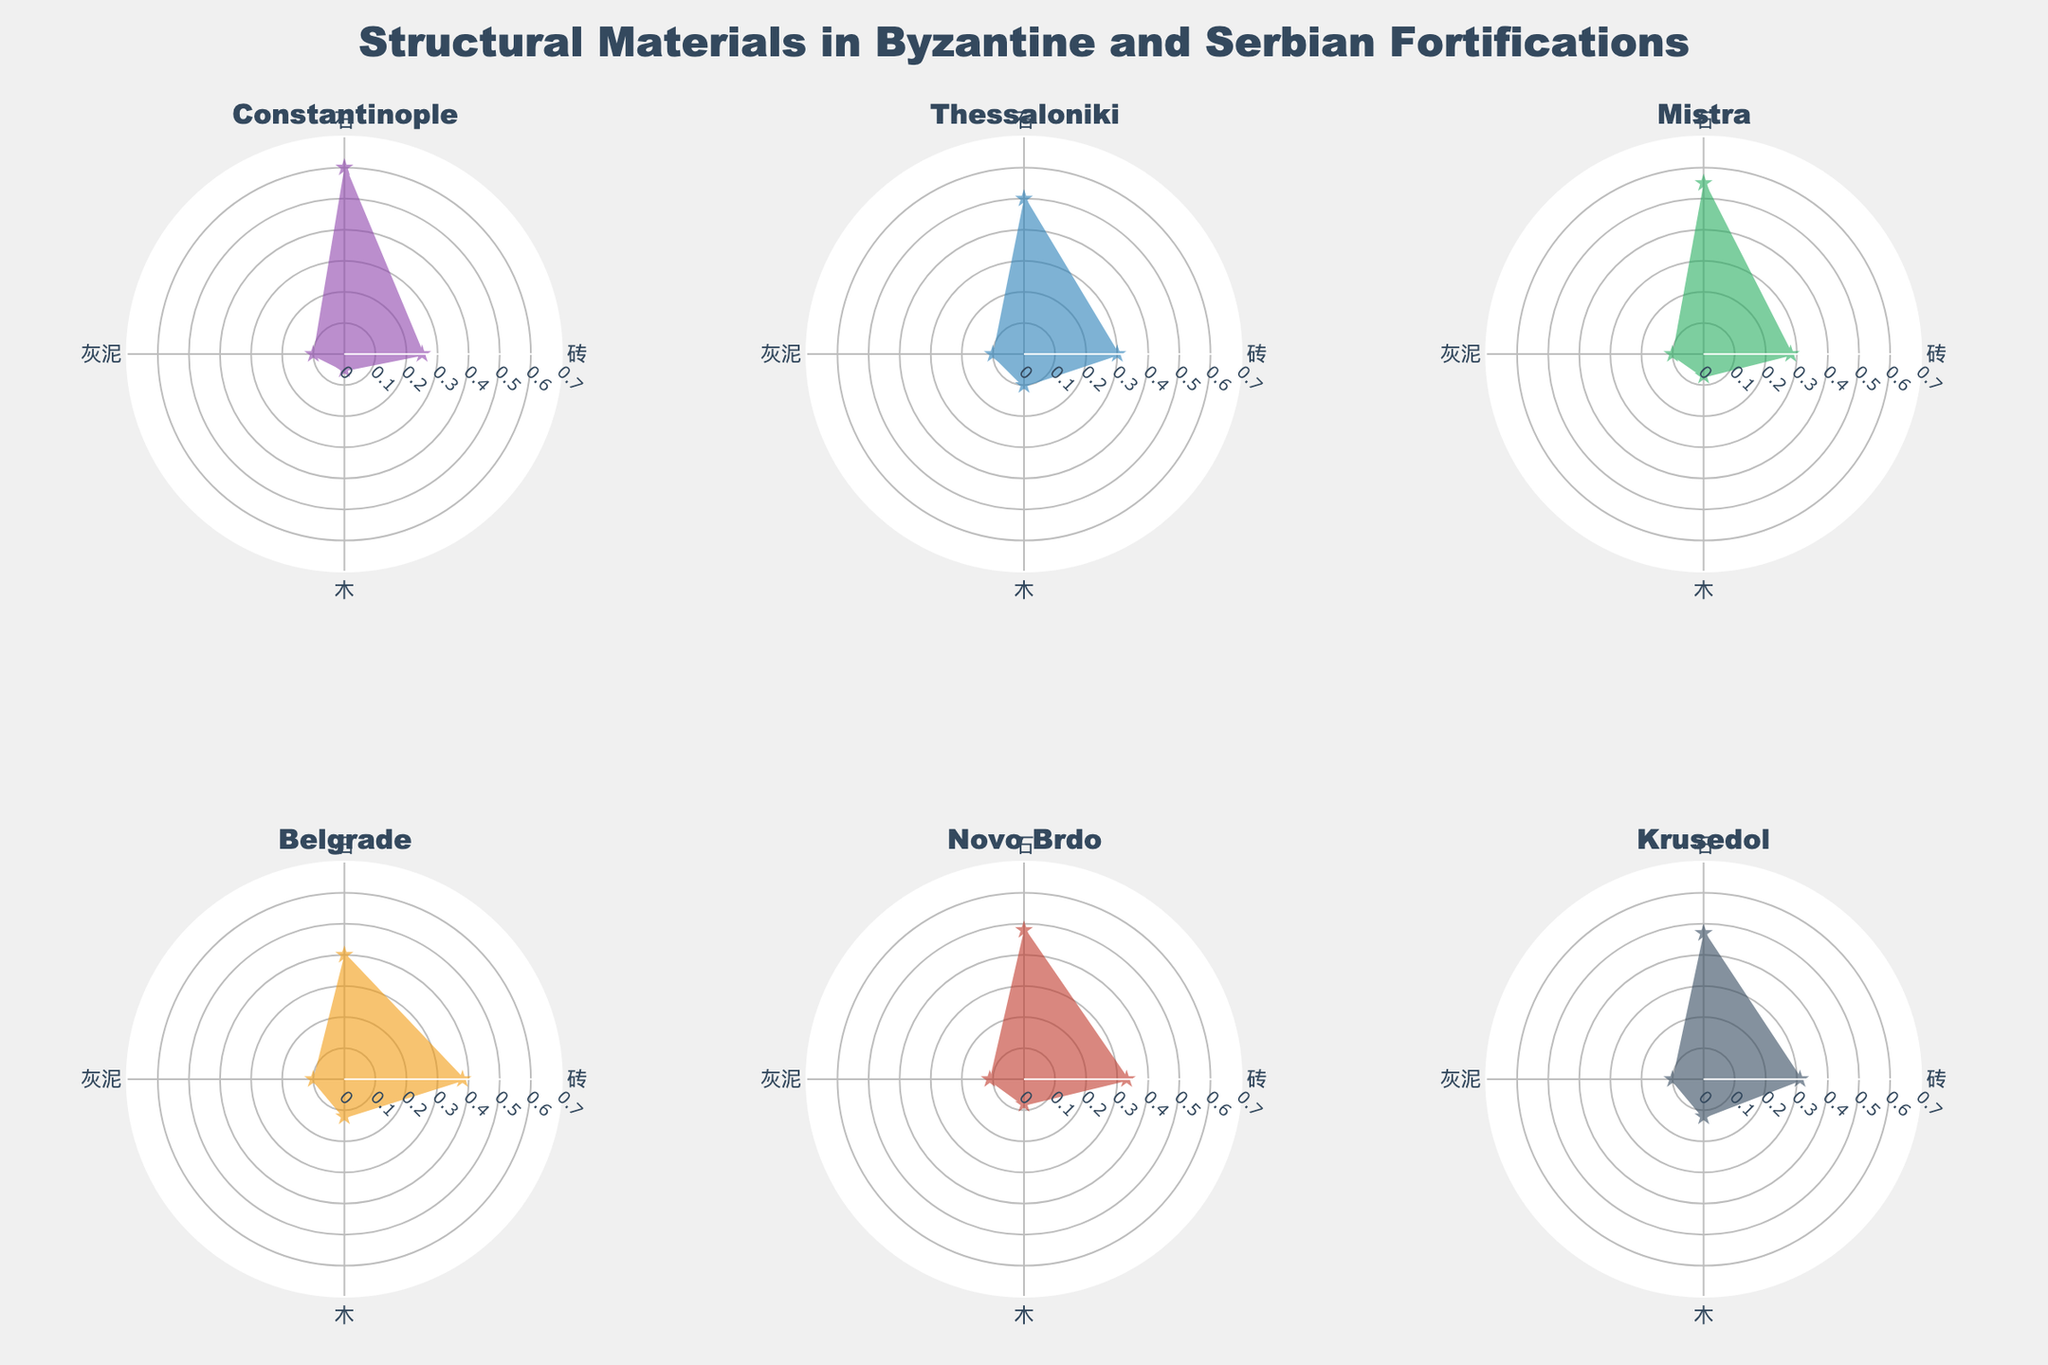What is the title of the figure? The title is positioned at the top center of the figure. It reads "Structural Materials in Byzantine and Serbian Fortifications."
Answer: Structural Materials in Byzantine and Serbian Fortifications Which city has the highest proportion of stone used in its fortifications? By examining the lengths of the stone (石) segments in each subplot, Constantinople has the longest segment, indicating the highest proportion.
Answer: Constantinople What material is used least in Belgrade fortifications? By analyzing the lengths of the segments in Belgrade's radar chart, wood (木) has the shortest segment.
Answer: Wood (木) Compare the proportion of brick used in Thessaloniki and Krusedol. Which city uses more brick in their fortifications? By comparing the lengths of the brick (砖) segments in Thessaloniki and Krusedol, Thessaloniki has a slightly longer segment, indicating a higher proportion.
Answer: Thessaloniki What is the average proportion of plaster used across all cities? To calculate this, sum the proportions of plaster (灰泥) for all cities (0.1 + 0.1 + 0.1 + 0.1 + 0.11 + 0.1) and divide by the number of cities (6). Therefore, (0.61)/6 = 0.1017.
Answer: 0.1017 Which city has a closer proportion of brick and stone used in its fortifications? By examining the radar charts, Krusedol shows proportions of brick (0.31) and stone (0.47) that are closer to each other compared to other cities.
Answer: Krusedol Is the proportion of wood used higher in Belgrade or Novo Brdo? By comparing the wood (木) segments in both radar charts, Novo Brdo has a slightly higher proportion than Belgrade.
Answer: Novo Brdo Combine the proportions of stone and plaster for Byzantium cities (Constantinople, Thessaloniki, Mistra). What is their total? The sum of the stone and plaster proportions for Constantinople (0.6 + 0.1), Thessaloniki (0.5 + 0.1), and Mistra (0.55 + 0.1) is 0.7 + 0.6 + 0.65 = 1.95.
Answer: 1.95 Which city’s radar chart shows the most balanced use of materials in its fortifications? By visually comparing the radar charts for all cities, Belgrade shows the most balanced segments across materials.
Answer: Belgrade 